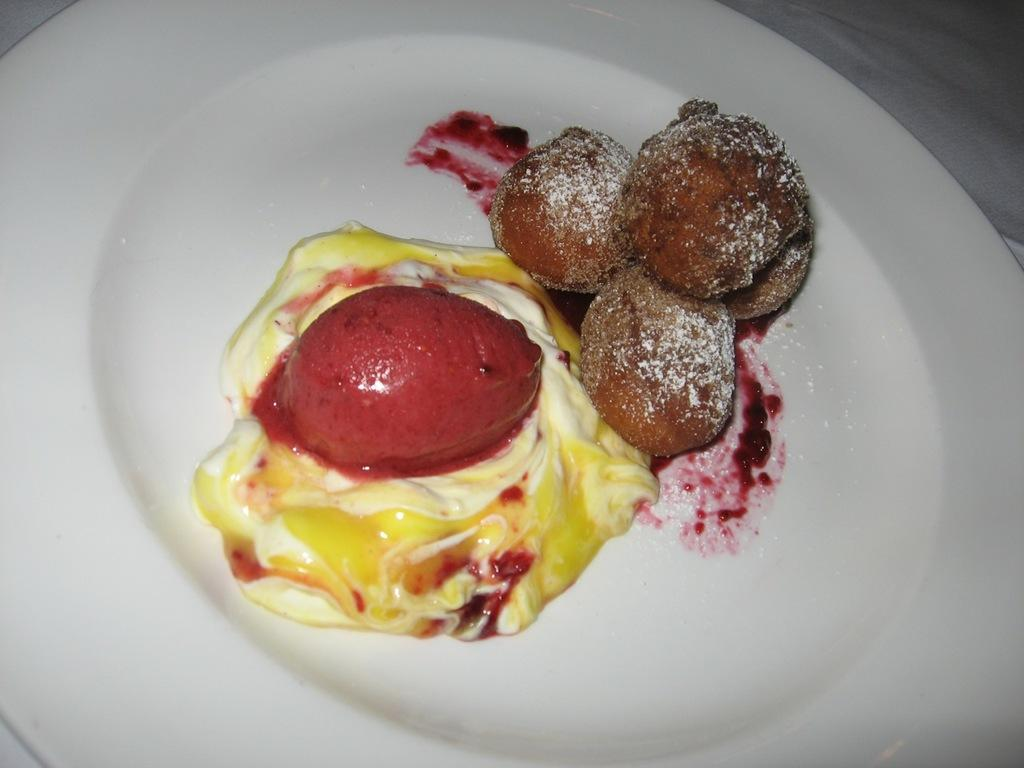What is on the plate that is visible in the image? There is a cream on a plate in the image. What else can be seen on the plate besides the cream? There are food items on the plate in the image. What color is the plate? The plate is white. Can you describe the background of the image? The background of the image is blurred. What type of wool is draped over the flag in the image? There is no wool or flag present in the image; it only features a plate with cream and food items. 